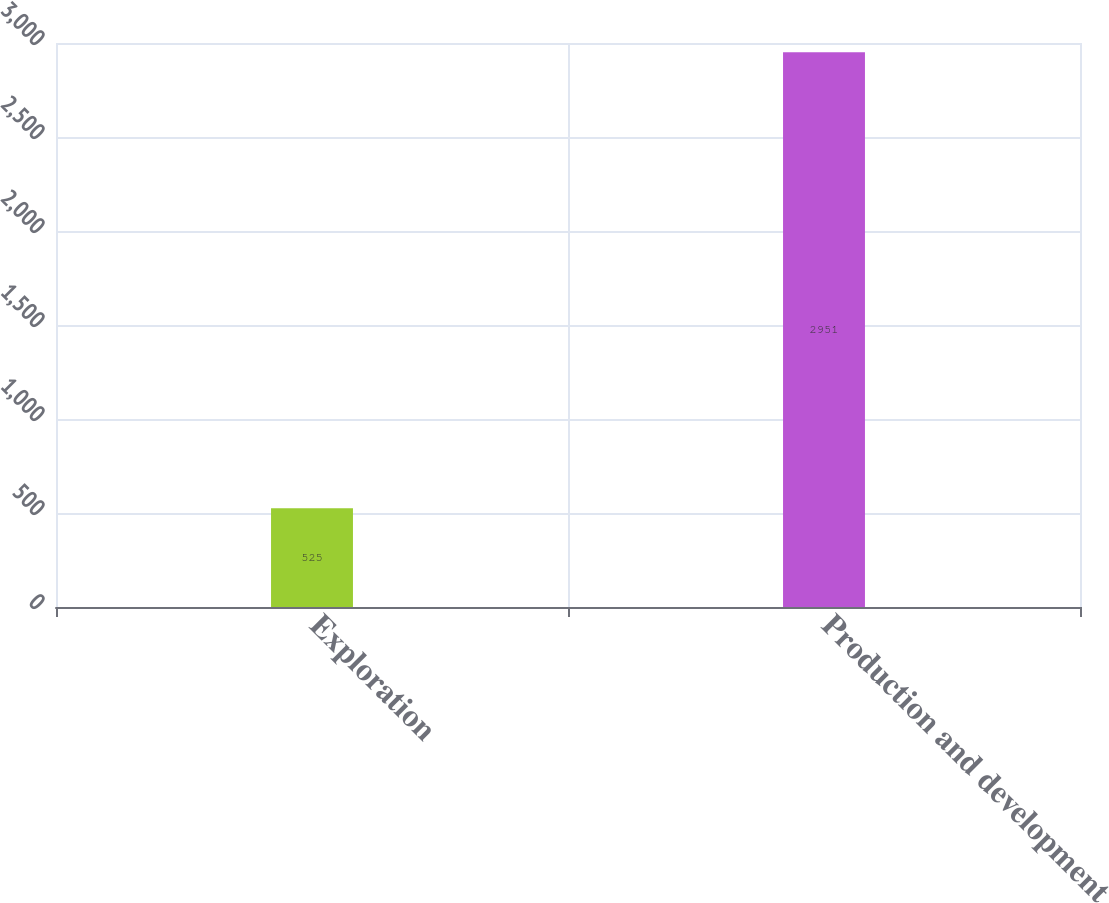Convert chart. <chart><loc_0><loc_0><loc_500><loc_500><bar_chart><fcel>Exploration<fcel>Production and development<nl><fcel>525<fcel>2951<nl></chart> 